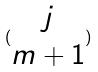Convert formula to latex. <formula><loc_0><loc_0><loc_500><loc_500>( \begin{matrix} j \\ m + 1 \end{matrix} )</formula> 